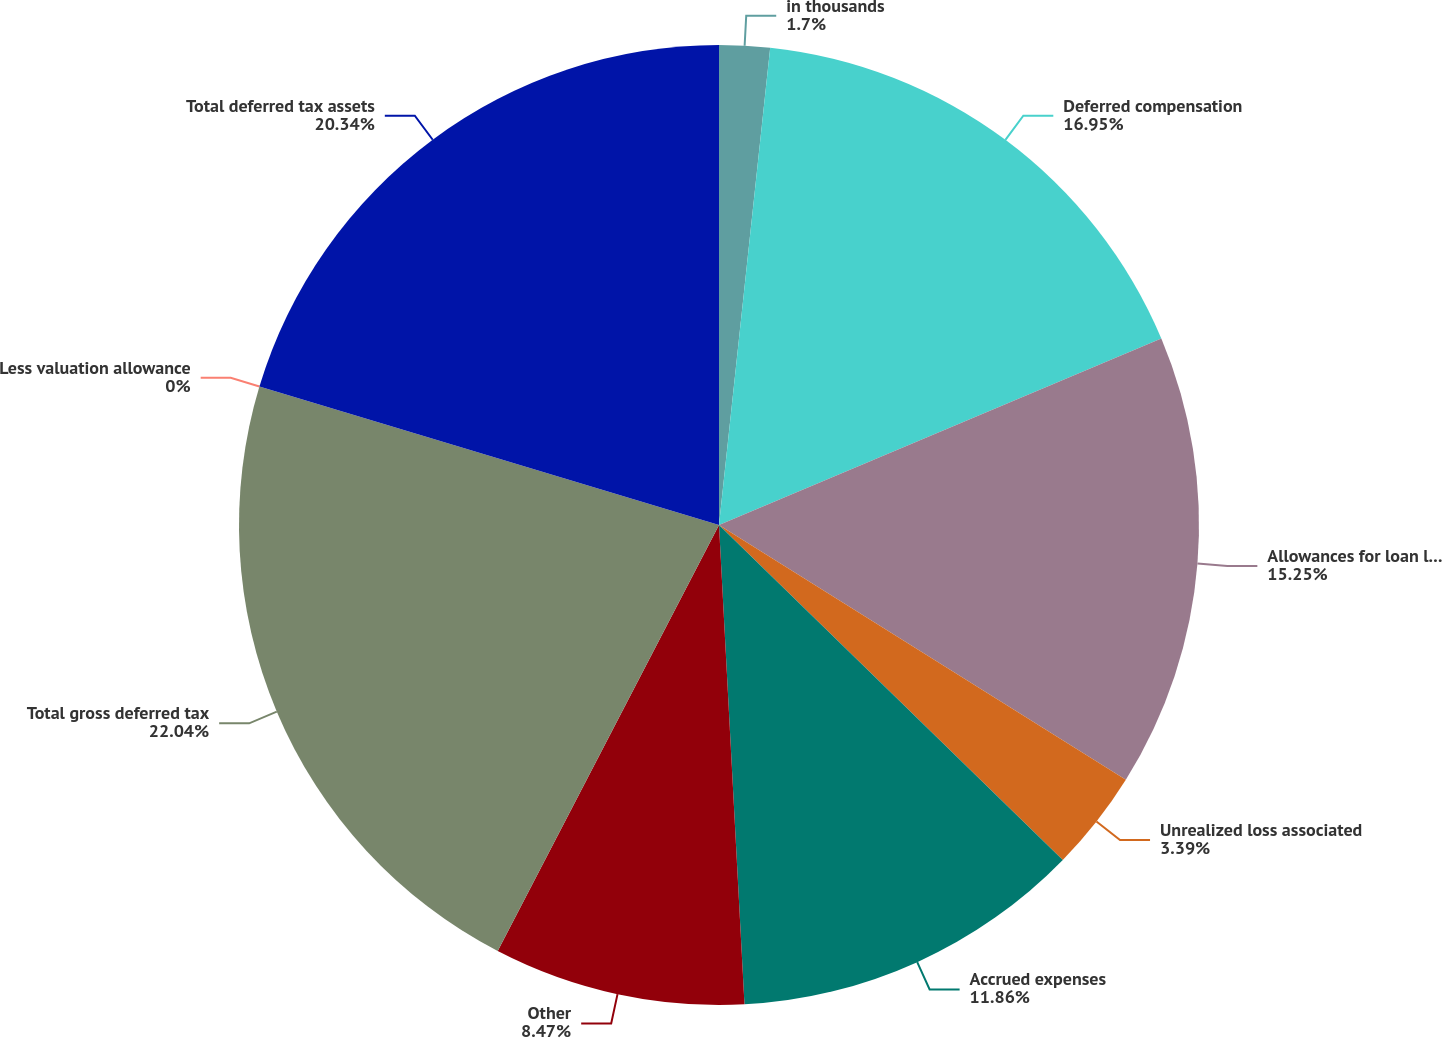Convert chart to OTSL. <chart><loc_0><loc_0><loc_500><loc_500><pie_chart><fcel>in thousands<fcel>Deferred compensation<fcel>Allowances for loan losses and<fcel>Unrealized loss associated<fcel>Accrued expenses<fcel>Other<fcel>Total gross deferred tax<fcel>Less valuation allowance<fcel>Total deferred tax assets<nl><fcel>1.7%<fcel>16.95%<fcel>15.25%<fcel>3.39%<fcel>11.86%<fcel>8.47%<fcel>22.03%<fcel>0.0%<fcel>20.34%<nl></chart> 